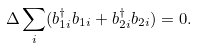Convert formula to latex. <formula><loc_0><loc_0><loc_500><loc_500>\Delta \sum _ { i } ( b ^ { \dagger } _ { 1 i } b _ { 1 i } + b ^ { \dagger } _ { 2 i } b _ { 2 i } ) = 0 .</formula> 